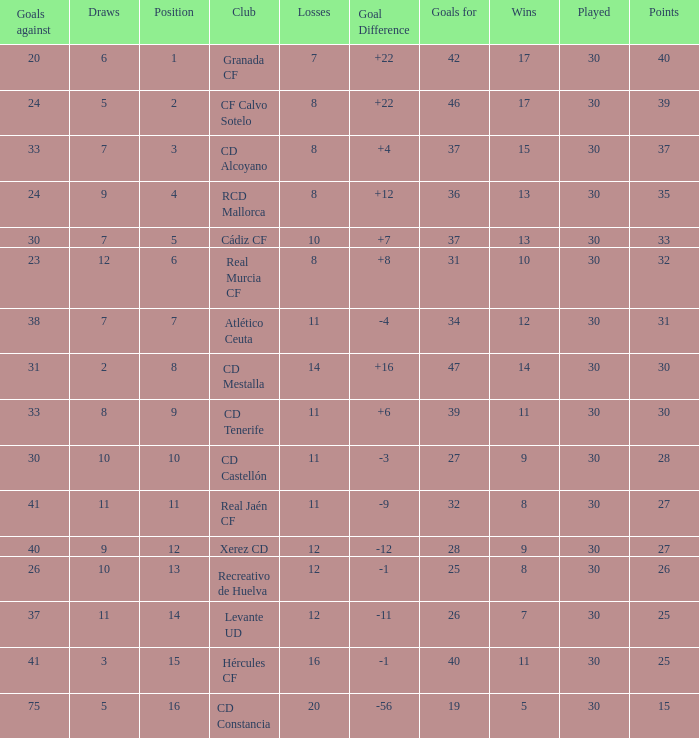How many Wins have Goals against smaller than 30, and Goals for larger than 25, and Draws larger than 5? 3.0. 